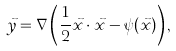Convert formula to latex. <formula><loc_0><loc_0><loc_500><loc_500>\vec { y } = \nabla \left ( \frac { 1 } { 2 } \vec { x } \cdot \vec { x } - \psi ( \vec { x } ) \right ) ,</formula> 